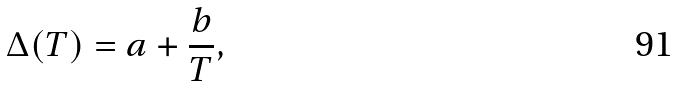<formula> <loc_0><loc_0><loc_500><loc_500>\Delta ( T ) = a + \frac { b } { T } ,</formula> 